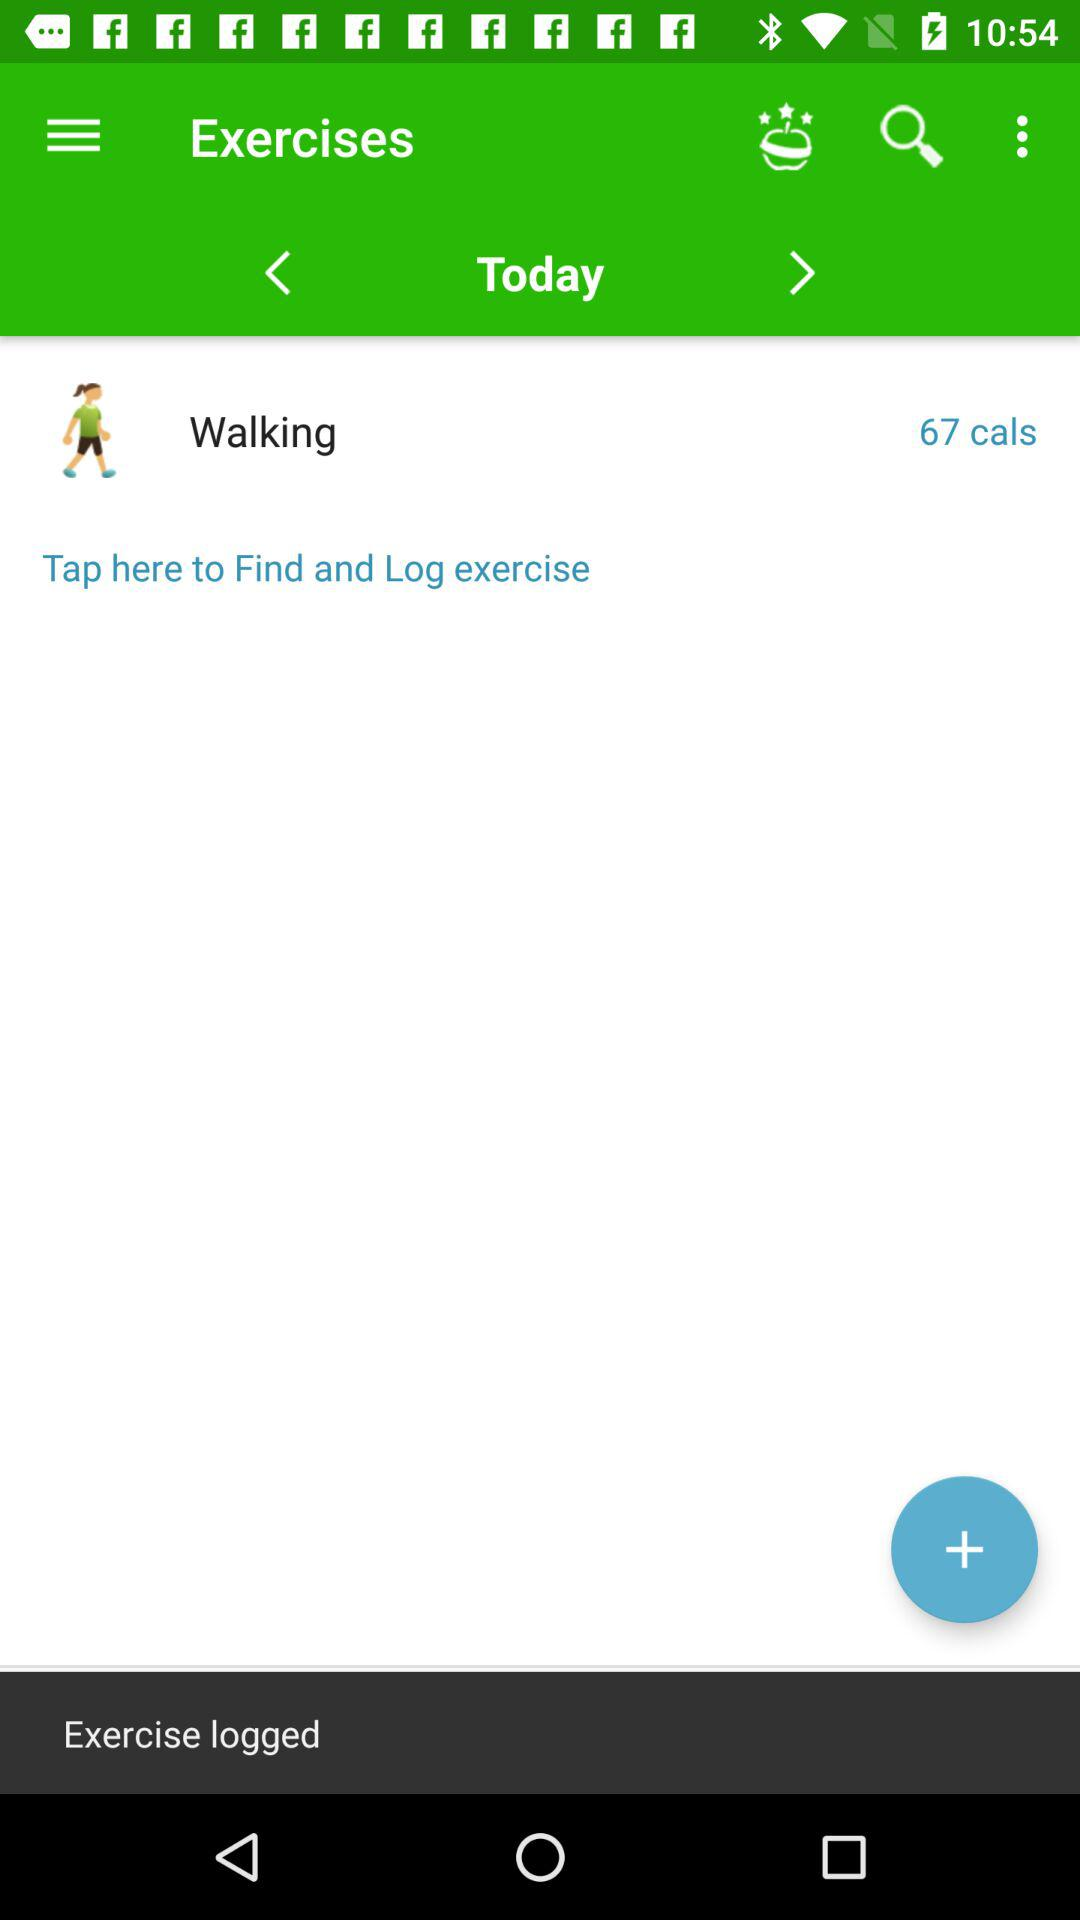What day is shown on the screen? The day is today. 